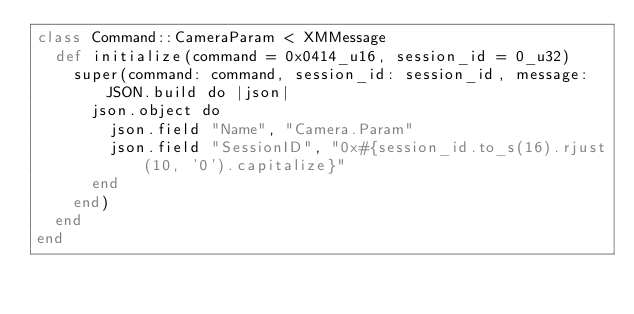Convert code to text. <code><loc_0><loc_0><loc_500><loc_500><_Crystal_>class Command::CameraParam < XMMessage
  def initialize(command = 0x0414_u16, session_id = 0_u32)
    super(command: command, session_id: session_id, message:  JSON.build do |json|
      json.object do
        json.field "Name", "Camera.Param"
        json.field "SessionID", "0x#{session_id.to_s(16).rjust(10, '0').capitalize}"
      end
    end)
  end
end
</code> 